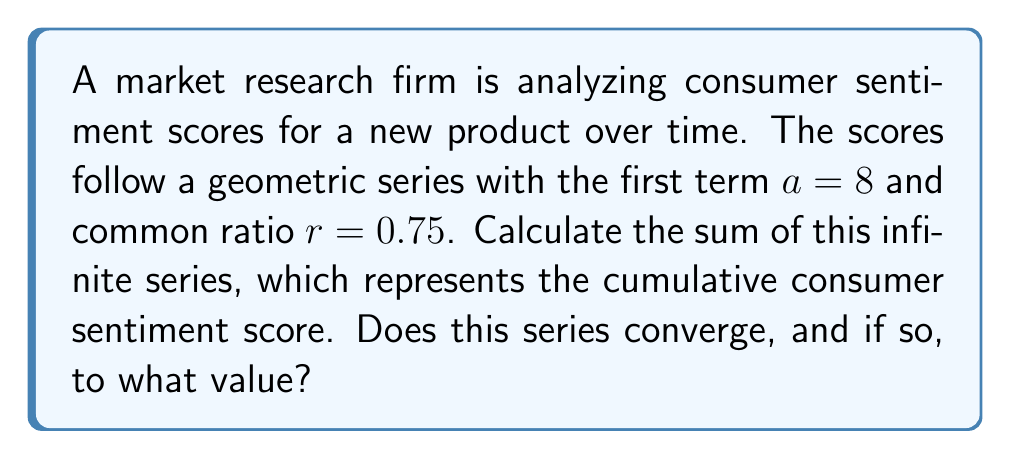Solve this math problem. To solve this problem, we'll follow these steps:

1) First, recall the formula for the sum of an infinite geometric series:
   
   $$S_{\infty} = \frac{a}{1-r}$$

   where $a$ is the first term and $r$ is the common ratio.

2) For this series to converge, we need $|r| < 1$. Let's check:
   
   $|r| = |0.75| = 0.75 < 1$

   Therefore, the series converges.

3) Now, let's substitute our values into the formula:
   
   $a = 8$
   $r = 0.75$

   $$S_{\infty} = \frac{8}{1-0.75}$$

4) Simplify:
   
   $$S_{\infty} = \frac{8}{0.25} = 32$$

Thus, the infinite series converges to 32.
Answer: The series converges to 32. 